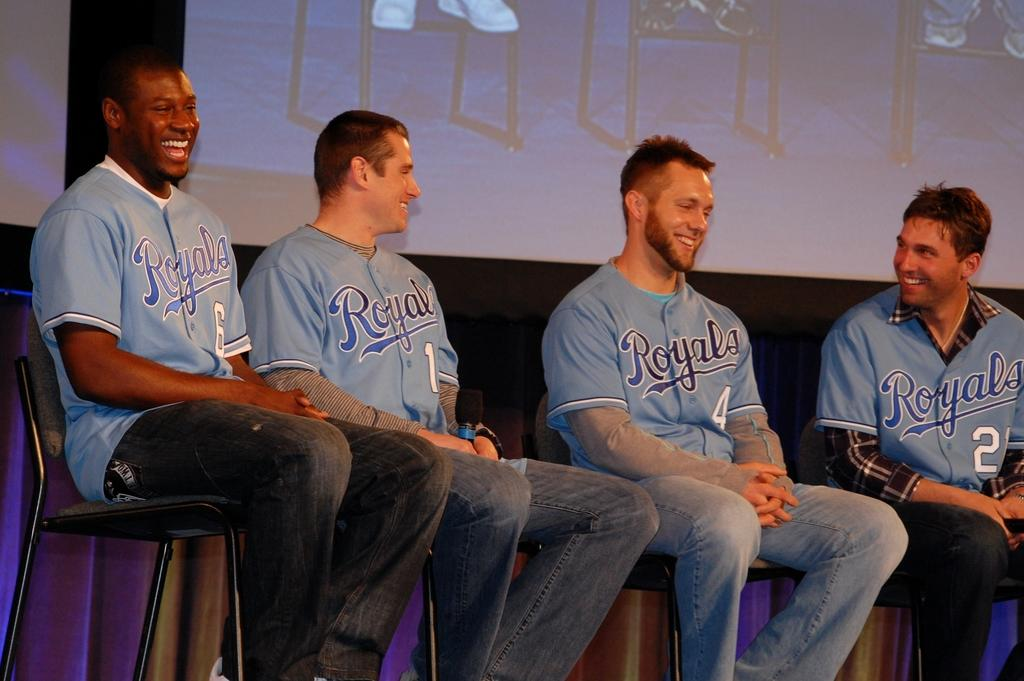How many people are in the image? There are four men in the image. What are the men doing in the image? The men are sitting on chairs and smiling. What is the purpose of the projector screen visible in the image? The projector screen is likely used for displaying information or visuals during a presentation or meeting. What type of meal are the men eating in the image? There is no meal present in the image; the men are sitting and smiling, but no food or eating is depicted. 